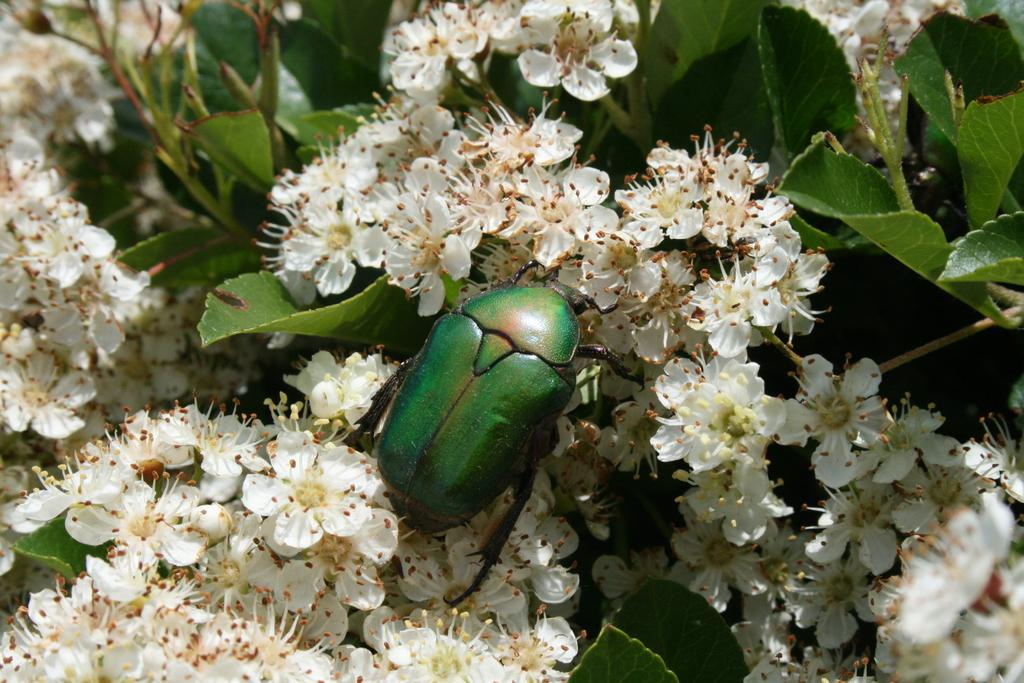What is the main subject in the center of the image? There is an insect in the center of the image. What can be seen in the background of the image? There are plants and flowers in the background of the image. What type of vein is visible in the image? There is no vein visible in the image; it features an insect and plants in the background. How many plantations are present in the image? There is no plantation present in the image; it features an insect and plants in the background. 